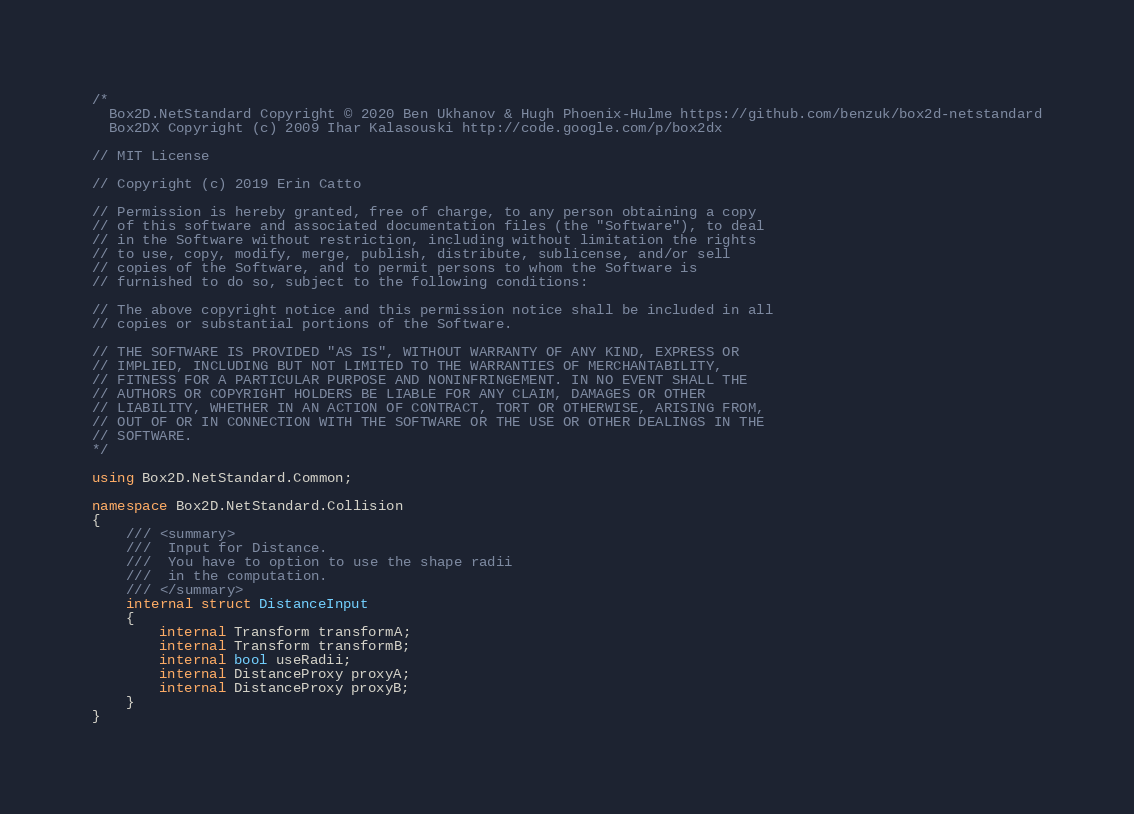<code> <loc_0><loc_0><loc_500><loc_500><_C#_>/*
  Box2D.NetStandard Copyright © 2020 Ben Ukhanov & Hugh Phoenix-Hulme https://github.com/benzuk/box2d-netstandard
  Box2DX Copyright (c) 2009 Ihar Kalasouski http://code.google.com/p/box2dx
  
// MIT License

// Copyright (c) 2019 Erin Catto

// Permission is hereby granted, free of charge, to any person obtaining a copy
// of this software and associated documentation files (the "Software"), to deal
// in the Software without restriction, including without limitation the rights
// to use, copy, modify, merge, publish, distribute, sublicense, and/or sell
// copies of the Software, and to permit persons to whom the Software is
// furnished to do so, subject to the following conditions:

// The above copyright notice and this permission notice shall be included in all
// copies or substantial portions of the Software.

// THE SOFTWARE IS PROVIDED "AS IS", WITHOUT WARRANTY OF ANY KIND, EXPRESS OR
// IMPLIED, INCLUDING BUT NOT LIMITED TO THE WARRANTIES OF MERCHANTABILITY,
// FITNESS FOR A PARTICULAR PURPOSE AND NONINFRINGEMENT. IN NO EVENT SHALL THE
// AUTHORS OR COPYRIGHT HOLDERS BE LIABLE FOR ANY CLAIM, DAMAGES OR OTHER
// LIABILITY, WHETHER IN AN ACTION OF CONTRACT, TORT OR OTHERWISE, ARISING FROM,
// OUT OF OR IN CONNECTION WITH THE SOFTWARE OR THE USE OR OTHER DEALINGS IN THE
// SOFTWARE.
*/

using Box2D.NetStandard.Common;

namespace Box2D.NetStandard.Collision
{
	/// <summary>
	///  Input for Distance.
	///  You have to option to use the shape radii
	///  in the computation.
	/// </summary>
	internal struct DistanceInput
	{
		internal Transform transformA;
		internal Transform transformB;
		internal bool useRadii;
		internal DistanceProxy proxyA;
		internal DistanceProxy proxyB;
	}
}</code> 